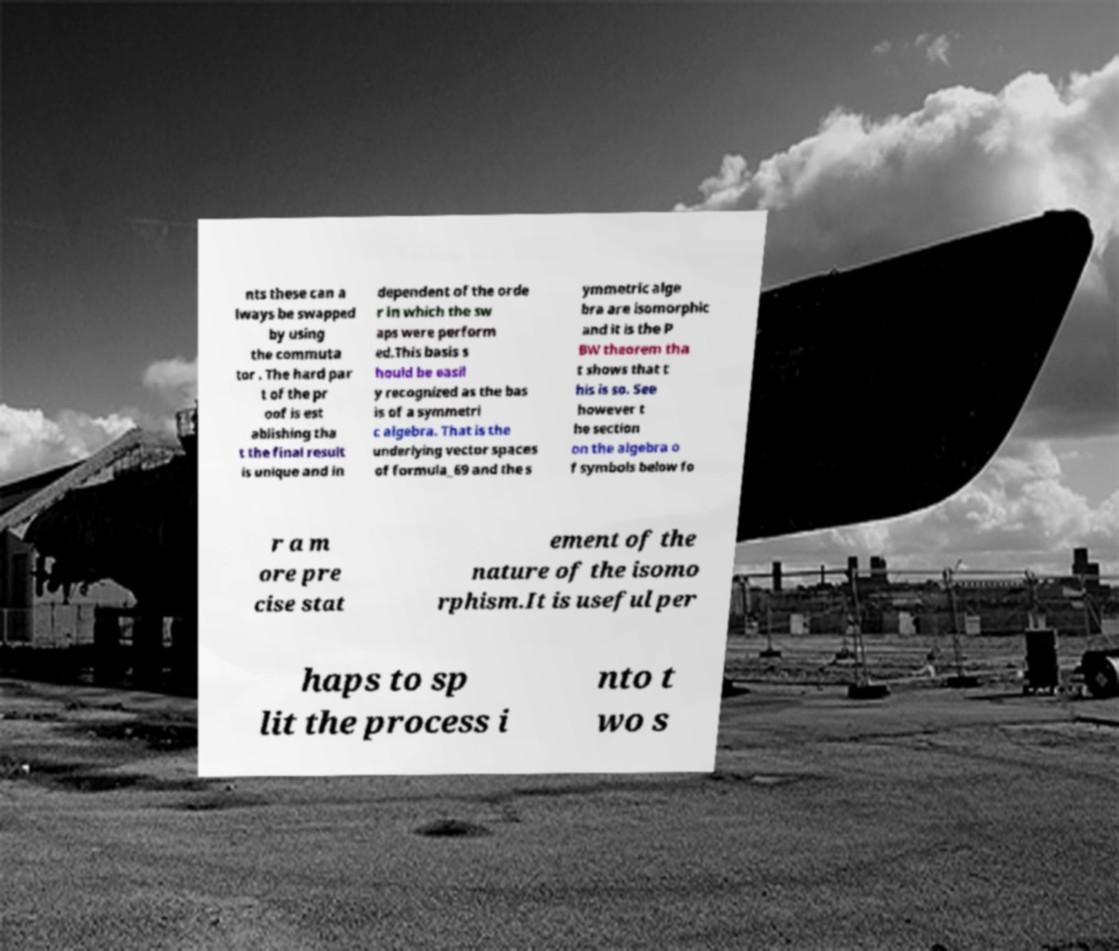Can you read and provide the text displayed in the image?This photo seems to have some interesting text. Can you extract and type it out for me? nts these can a lways be swapped by using the commuta tor . The hard par t of the pr oof is est ablishing tha t the final result is unique and in dependent of the orde r in which the sw aps were perform ed.This basis s hould be easil y recognized as the bas is of a symmetri c algebra. That is the underlying vector spaces of formula_69 and the s ymmetric alge bra are isomorphic and it is the P BW theorem tha t shows that t his is so. See however t he section on the algebra o f symbols below fo r a m ore pre cise stat ement of the nature of the isomo rphism.It is useful per haps to sp lit the process i nto t wo s 